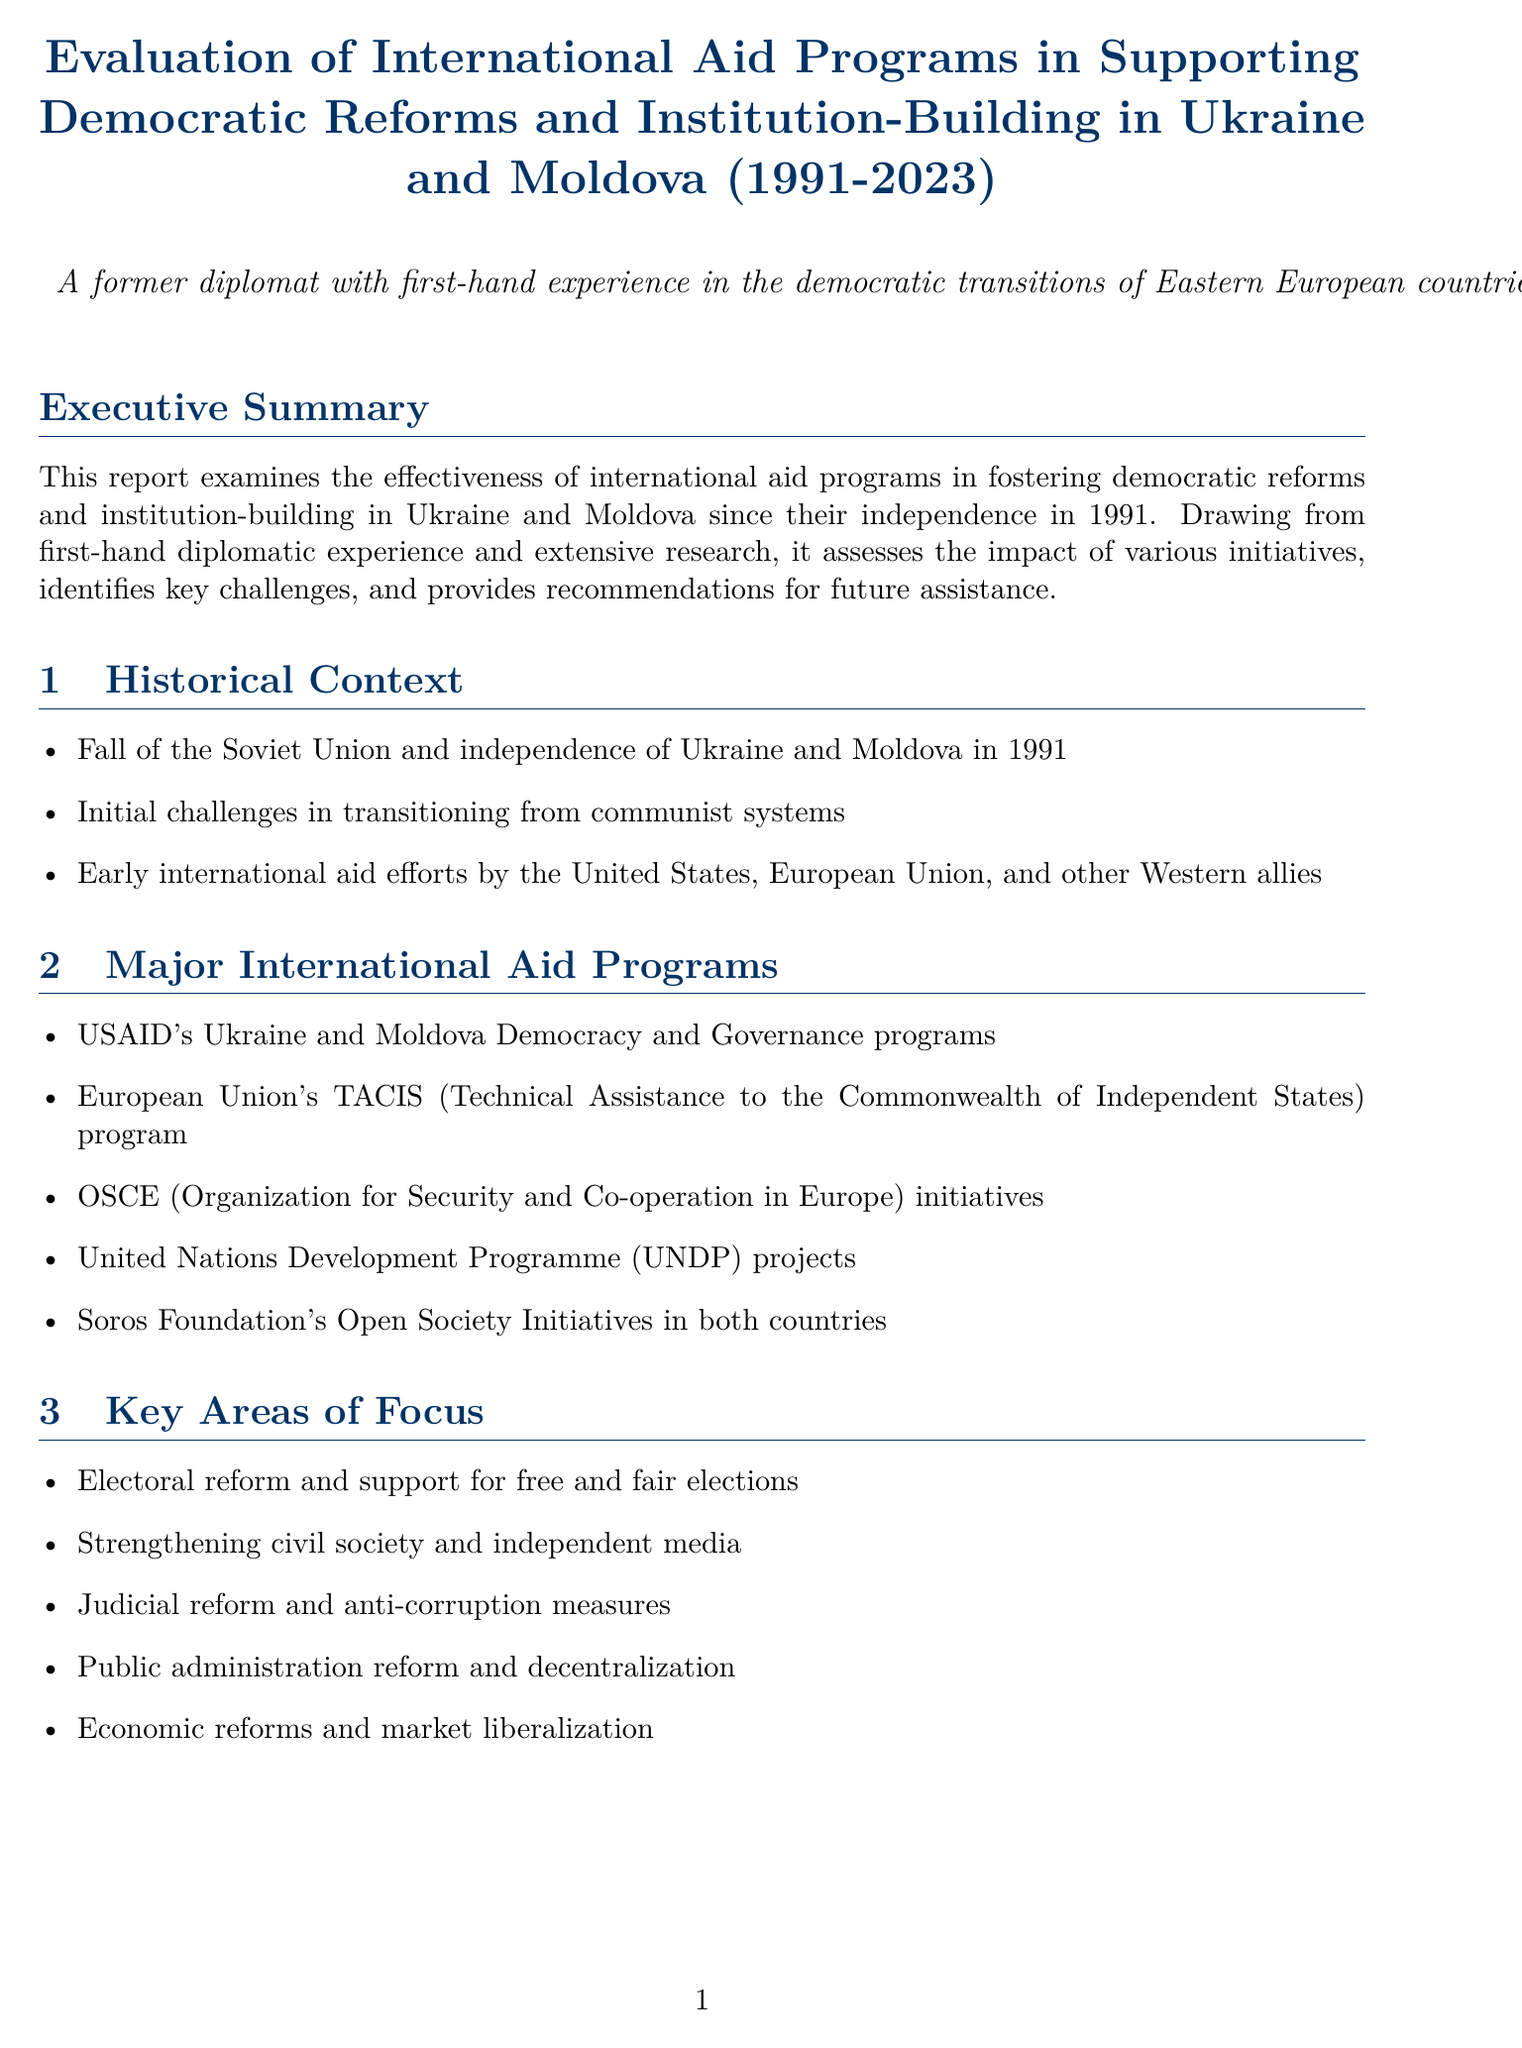What is the report title? The title appears at the beginning of the document, indicating the focus of the evaluation.
Answer: Evaluation of International Aid Programs in Supporting Democratic Reforms and Institution-Building in Ukraine and Moldova (1991-2023) What year did Ukraine and Moldova gain independence? This information is found in the Historical Context section, which discusses the early years of both countries.
Answer: 1991 How much USAID assistance did Ukraine receive from 1992 to 2023? The data point provides specific funding amounts allocated by USAID throughout the years.
Answer: $5 billion What is Moldova's Freedom House Democracy Score for 2023? This score is mentioned in the Data Points section and reflects the level of democratic practices in the country.
Answer: 62/100 What is a key area of focus outlined in the report? The content of the report lists several areas that received attention and resources for development.
Answer: Electoral reform and support for free and fair elections Who is the current President of Ukraine? This information is found in the Key Figures section, identifying prominent leaders relevant to the report.
Answer: Volodymyr Zelenskyy What challenge is highlighted as a setback for democratic reforms? The Challenges and Setbacks section outlines various issues hindering progress in both countries.
Answer: Persistent corruption and oligarchic influence What is one recommendation made in the report? The Recommendations section provides strategic advice for future international aid efforts.
Answer: Enhance support for anti-corruption initiatives and judicial reform 